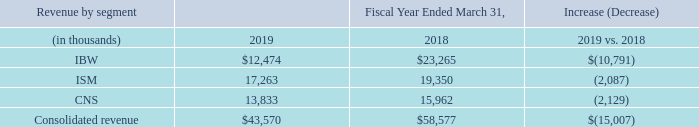Revenue by segment
IBW segment revenue decreased $10.8 million, in fiscal year 2019 when compared to fiscal year 2018, primarily due to lower sales of DAS conditioners, commercial repeaters, and related ancillary products (passive RF system components and antennas).
Lower sales of DAS conditioners, which includes our Universal DAS Interface Tray (UDIT) active conditioner, were the largest contributor to the year-over-year decline. The overall market for these stand-alone conditioners is expected to continue to decline over time, as their key function, the attenuation of the RF signal from its high-power source to low-power required for a DAS, becomes more integrated into the DAS head-ends themselves (or in some applications, a low enough power level may already be provided by the RF source). Further, in the fourth fiscal quarter of 2018, one service provider that had previously been a large UDIT buyer made an unexpectedly abrupt network architecture shift to an alternative, non-DAS solution for their in-building coverage. This resulted in an even sharper decline during fiscal year 2019 compared to fiscal year 2018. We expect the current lower levels of UDIT revenue to be flat-to-down in the future, with its primary market coming from capacity expansions at existing sites where embedded DAS networks included UDIT.  Lower sales of DAS conditioners, which includes our Universal DAS Interface Tray (UDIT) active conditioner, were the largest contributor to the year-over-year decline. The overall market for these stand-alone conditioners is expected to continue to decline over time, as their key function, the attenuation of the RF signal from its high-power source to low-power required for a DAS, becomes more integrated into the DAS head-ends themselves (or in some applications, a low enough power level may already be provided by the RF source). Further, in the fourth fiscal quarter of 2018, one service provider that had previously been a large UDIT buyer made an unexpectedly abrupt network architecture shift to an alternative, non-DAS solution for their in-building coverage. This resulted in an even sharper decline during fiscal year 2019 compared to fiscal year 2018. We expect the current lower levels of UDIT revenue to be flat-to-down in the future, with its primary market coming from capacity expansions at existing sites where embedded DAS networks included UDIT.
Lower sales of commercial repeaters, while still a reliable and proven solution for amplifying cellular coverage inside a building, are reflective of the continuing downward-demand trend as our larger customers have had a stronger preference for small cells to provide in-building cellular coverage. We expect this trend to continue.
The decrease from ancillary products (passive RF system components and antennas) revenue is largely a function of the decline in sales of DAS conditioners and commercial repeaters. Future ancillary product revenue can follow the same flat-to-down trend as DAS conditioners and commercial repeaters, or potentially increase in tandem with an increase in public safety revenue.
In fiscal year 2019, the Company spent considerable resources, with a partner, to bring a new suite of public safety products to market. When compared to our current public safety repeaters, these products would include additional capacities, frequency ranges, features, and channelization that would significantly expand our offering to a larger public safety addressable market. We continue to work with our partner on product testing and delivery time frames and, if successful, we would expect future revenue growth in this market.
ISM segment revenue decreased$2.1 million in fiscal year 2019 when compared to fiscal year 2018. The year-over-year decrease was primarily due to a decline in deployment (i.e., installation) services revenue. Deployment services revenue had been largely dependent on one domestic customer that continues to buy our ISM remotes and support services but that, subsequent to a price increase, no longer places orders with us for deployment services. Secondarily, the ISM revenue decrease was also attributable to lower sales of our Optima network management software. Due to the project-based nature of our ISM business, it is difficult to make a determination on future trends.
CNS segment revenue decreased$2.1 million in fiscal year 2019 when compared to fiscal year2018, due primarily to the expected lower sales of integrated cabinets, which are heavily project-based and historically high in customer concentration. There was a significant decrease in fiscal year 2019 from two of our historically larger customers for integrated cabinets - one where we customized integrated cabinets for a neutral host operator providing wireless coverage in the New York City subway and the other, a rural broadband service provider.
The expected lower sales of T1 NIUs and TMAs, as the products serve declining markets, also contributed to the CNS segment revenue decline.
Partly offsetting the declines from integrated cabinets, T1 NIUs, and TMAs, was increased revenue from our copper/fiber network connectivity products as well as revenue from products newly introduced during fiscal year 2019 as part of our fiber access growth initiative.
For CNS, we expect fiber access revenue to grow; power distribution and network connectivity products to remain flat; T1 NIU and TMA revenue to continue to decrease; and sales of integrated cabinets, which are heavily project-based, to remain uneven.
Why did IBW segment revenue decrease in 2019 compared to 2018? Lower sales of das conditioners, commercial repeaters, and related ancillary products (passive rf system components and antennas). What is largely a function of the decline in sales of DAS conditioners and commercial repeaters? The decrease from ancillary products (passive rf system components and antennas) revenue. What did deployment services revenue largely depend on? One domestic customer that continues to buy our ism remotes and support services but that, subsequent to a price increase, no longer places orders with us for deployment services. What is the proportion of revenue from the IBW and ISM segment over total revenue in 2018? (23,265+19,350)/58,577 
Answer: 0.73. What is the percentage change in revenue from the CNS segment in 2019 compared to 2018?
Answer scale should be: percent. -2,129/15,962 
Answer: -13.34. What is the average revenue from all three segments in 2019?
Answer scale should be: thousand. (12,474+17,263+13,833)/3 
Answer: 14523.33. 